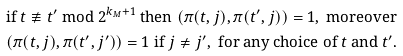Convert formula to latex. <formula><loc_0><loc_0><loc_500><loc_500>& \text {if } t \not \equiv t ^ { \prime } \text { mod } 2 ^ { k _ { M } + 1 } \text { then } ( \pi ( t , j ) , \pi ( t ^ { \prime } , j ) ) = 1 , \text { moreover} \\ & ( \pi ( t , j ) , \pi ( t ^ { \prime } , j ^ { \prime } ) ) = 1 \text { if } j \not = j ^ { \prime } , \text { for any choice of } t \text { and } t ^ { \prime } .</formula> 